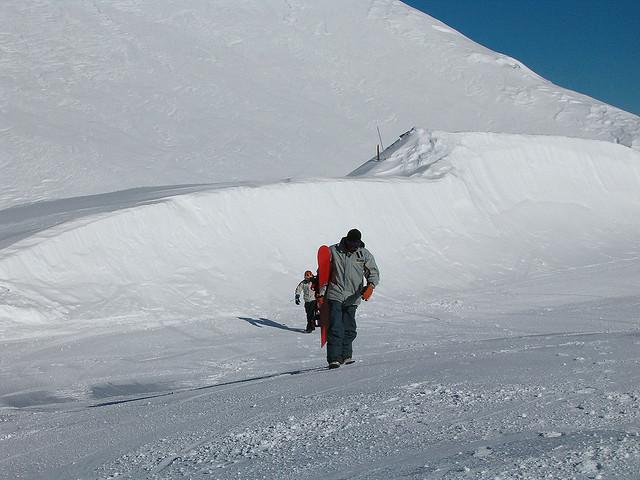What color is the person's jacket?
Give a very brief answer. Gray. What is the caring?
Answer briefly. Snowboard. How fast is the person going?
Quick response, please. Slow. Who is with this person?
Give a very brief answer. Friend. What color is the board?
Be succinct. Red. What is the man wearing on his hands?
Write a very short answer. Gloves. Is this a sport for the faint of heart?
Answer briefly. No. 